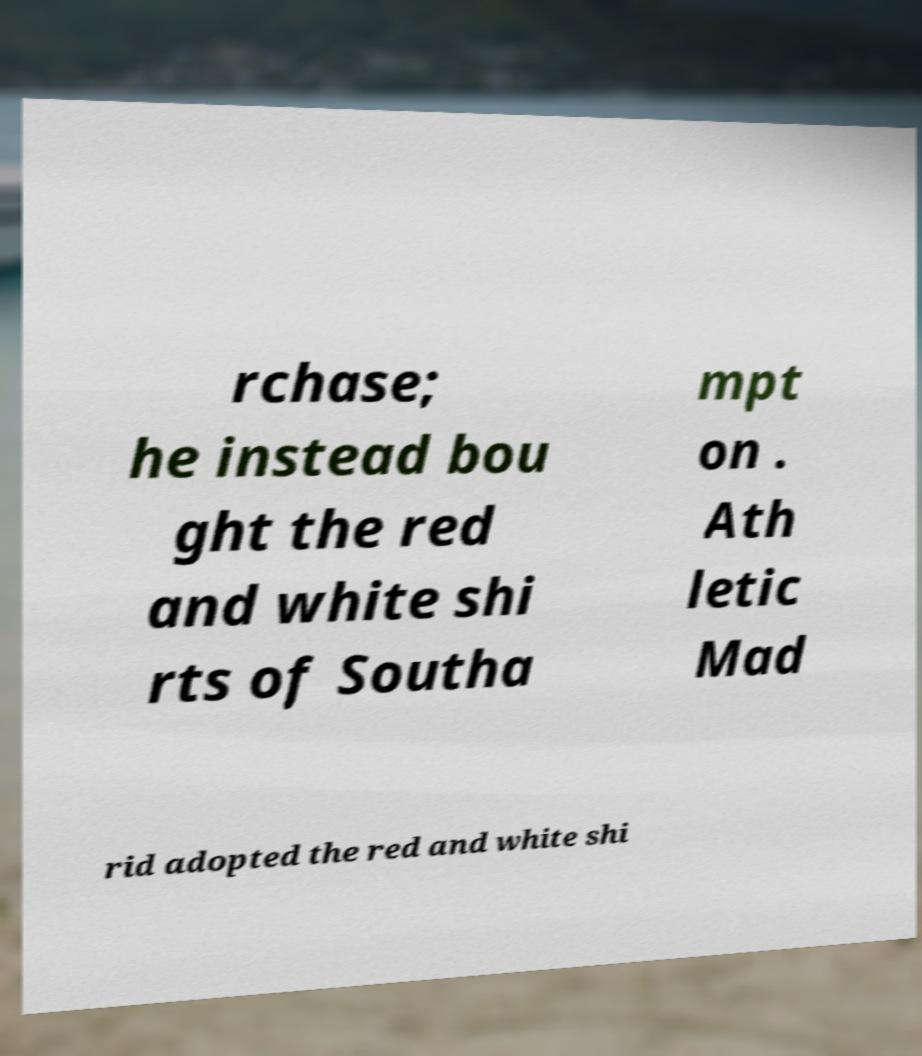For documentation purposes, I need the text within this image transcribed. Could you provide that? rchase; he instead bou ght the red and white shi rts of Southa mpt on . Ath letic Mad rid adopted the red and white shi 